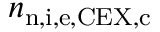<formula> <loc_0><loc_0><loc_500><loc_500>n _ { n , i , e , C E X , c }</formula> 